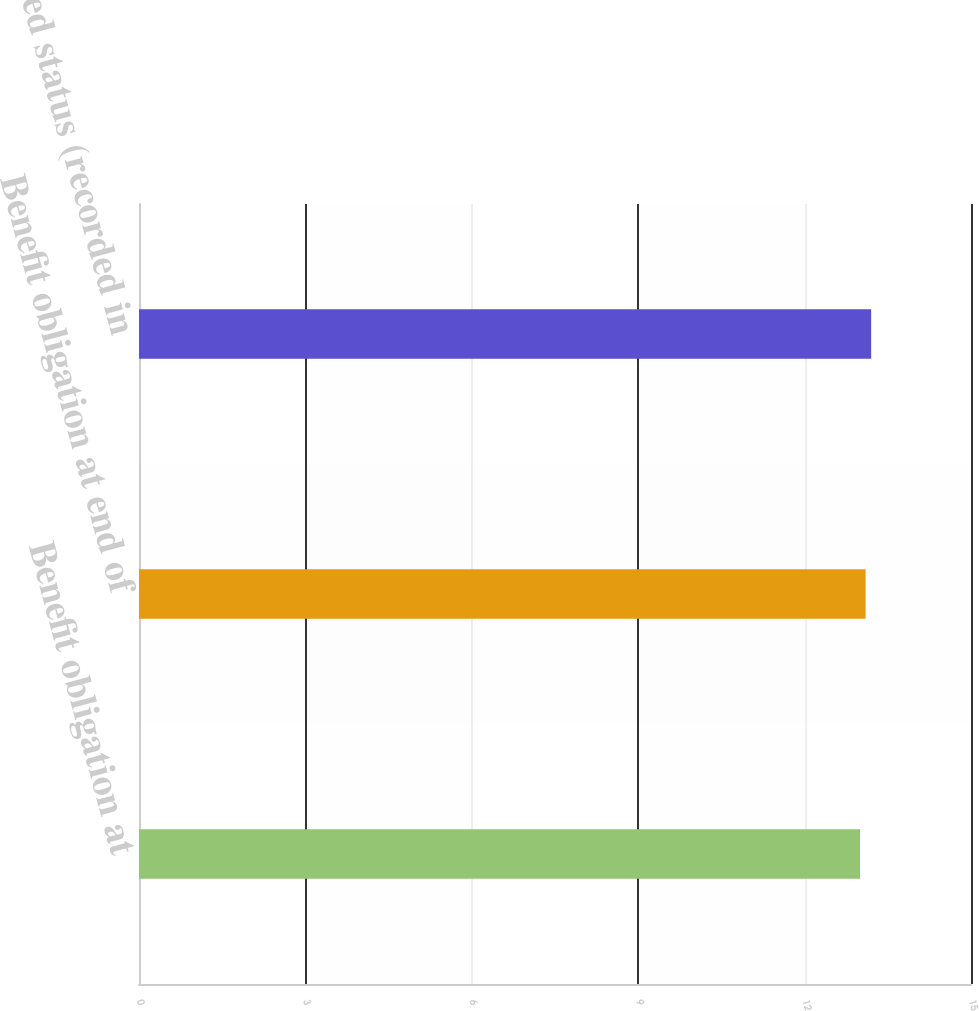<chart> <loc_0><loc_0><loc_500><loc_500><bar_chart><fcel>Benefit obligation at<fcel>Benefit obligation at end of<fcel>Funded status (recorded in<nl><fcel>13<fcel>13.1<fcel>13.2<nl></chart> 